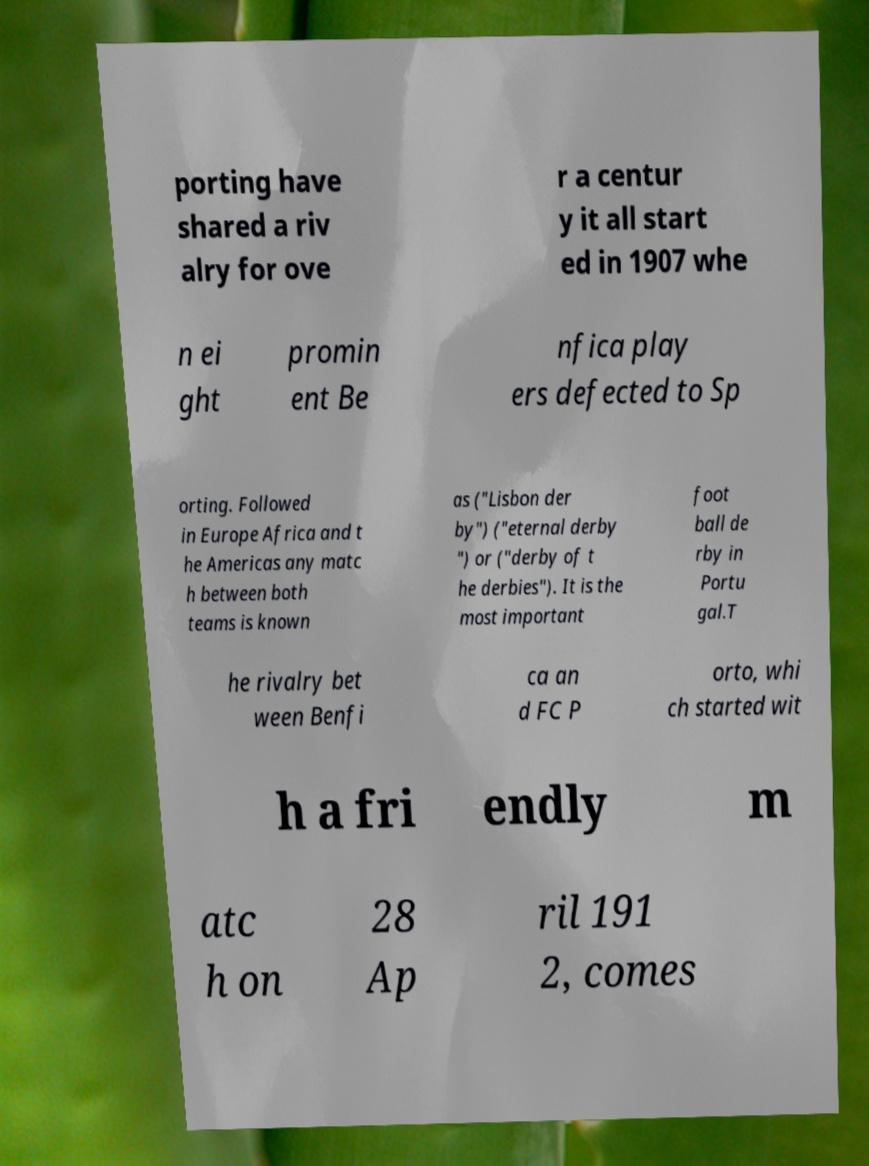There's text embedded in this image that I need extracted. Can you transcribe it verbatim? porting have shared a riv alry for ove r a centur y it all start ed in 1907 whe n ei ght promin ent Be nfica play ers defected to Sp orting. Followed in Europe Africa and t he Americas any matc h between both teams is known as ("Lisbon der by") ("eternal derby ") or ("derby of t he derbies"). It is the most important foot ball de rby in Portu gal.T he rivalry bet ween Benfi ca an d FC P orto, whi ch started wit h a fri endly m atc h on 28 Ap ril 191 2, comes 